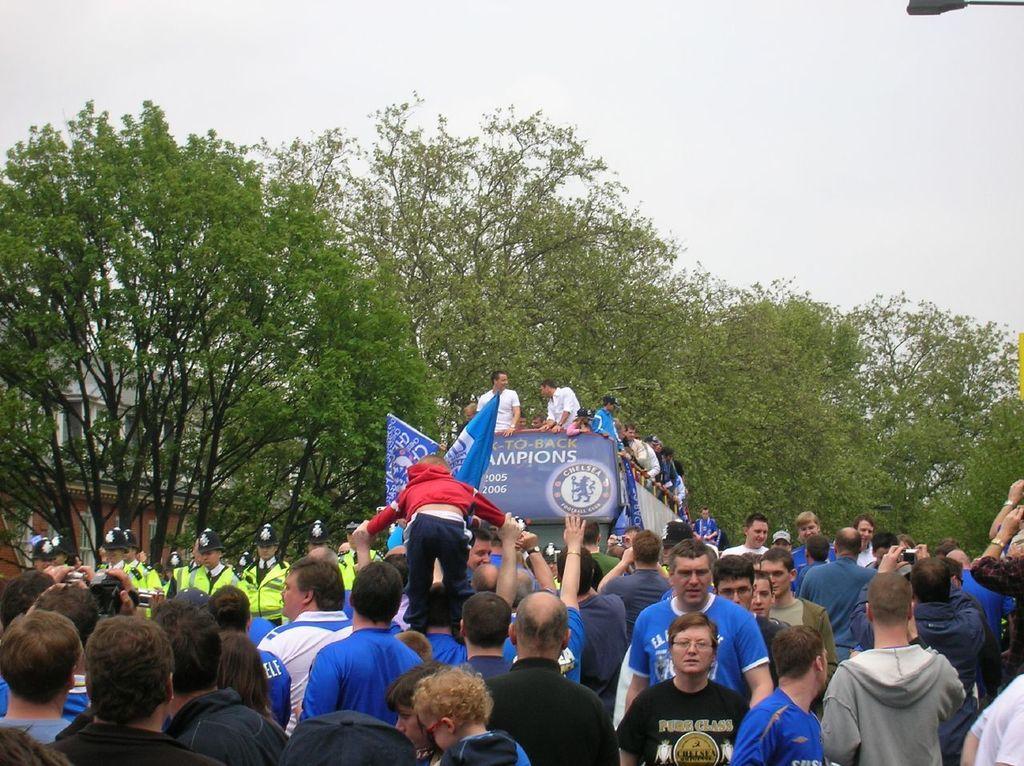Can you describe this image briefly? In this picture I can see a group of people in the middle, it looks like a vehicle. In the background I can see few trees, at the top there is the sky. On the left side there is a building. 